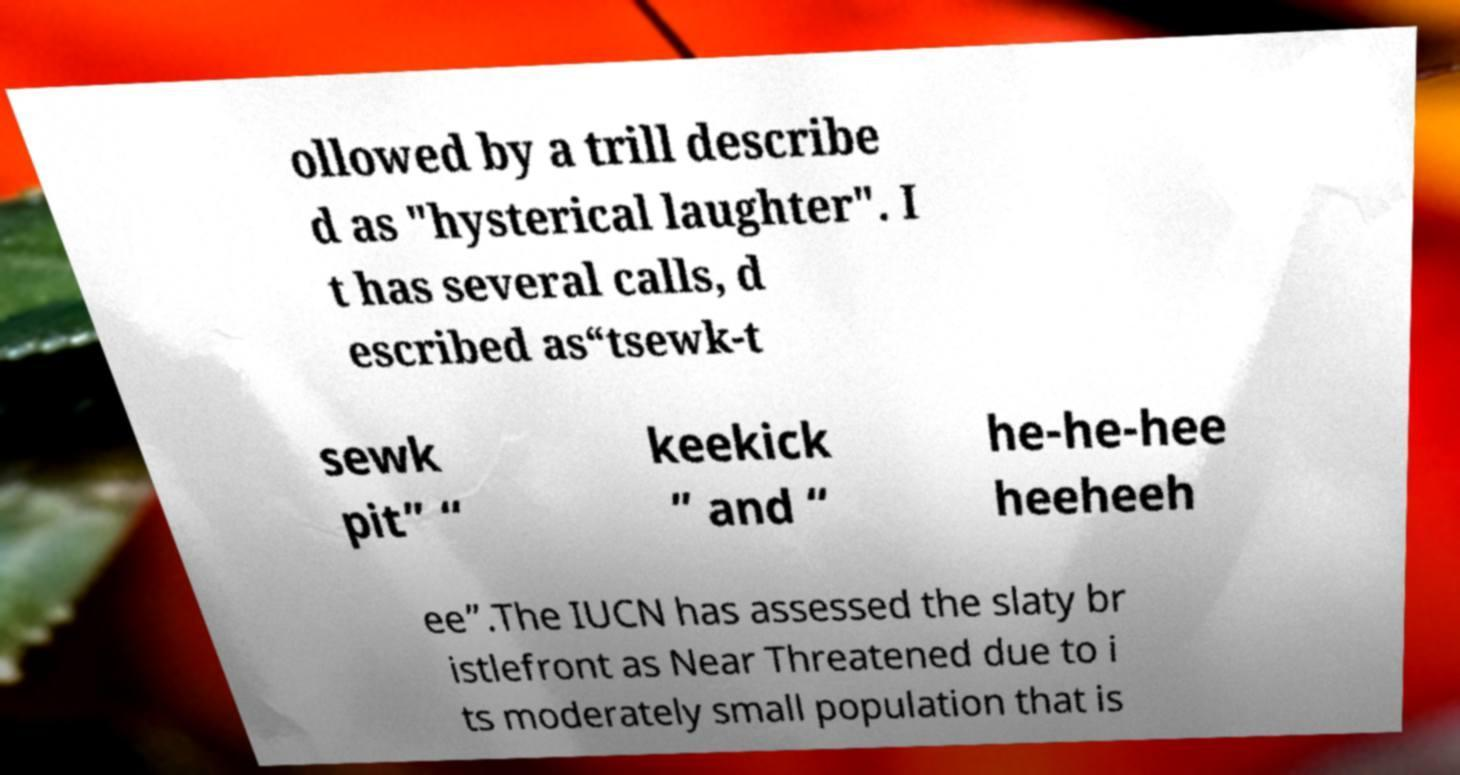For documentation purposes, I need the text within this image transcribed. Could you provide that? ollowed by a trill describe d as "hysterical laughter". I t has several calls, d escribed as“tsewk-t sewk pit” “ keekick ” and “ he-he-hee heeheeh ee”.The IUCN has assessed the slaty br istlefront as Near Threatened due to i ts moderately small population that is 